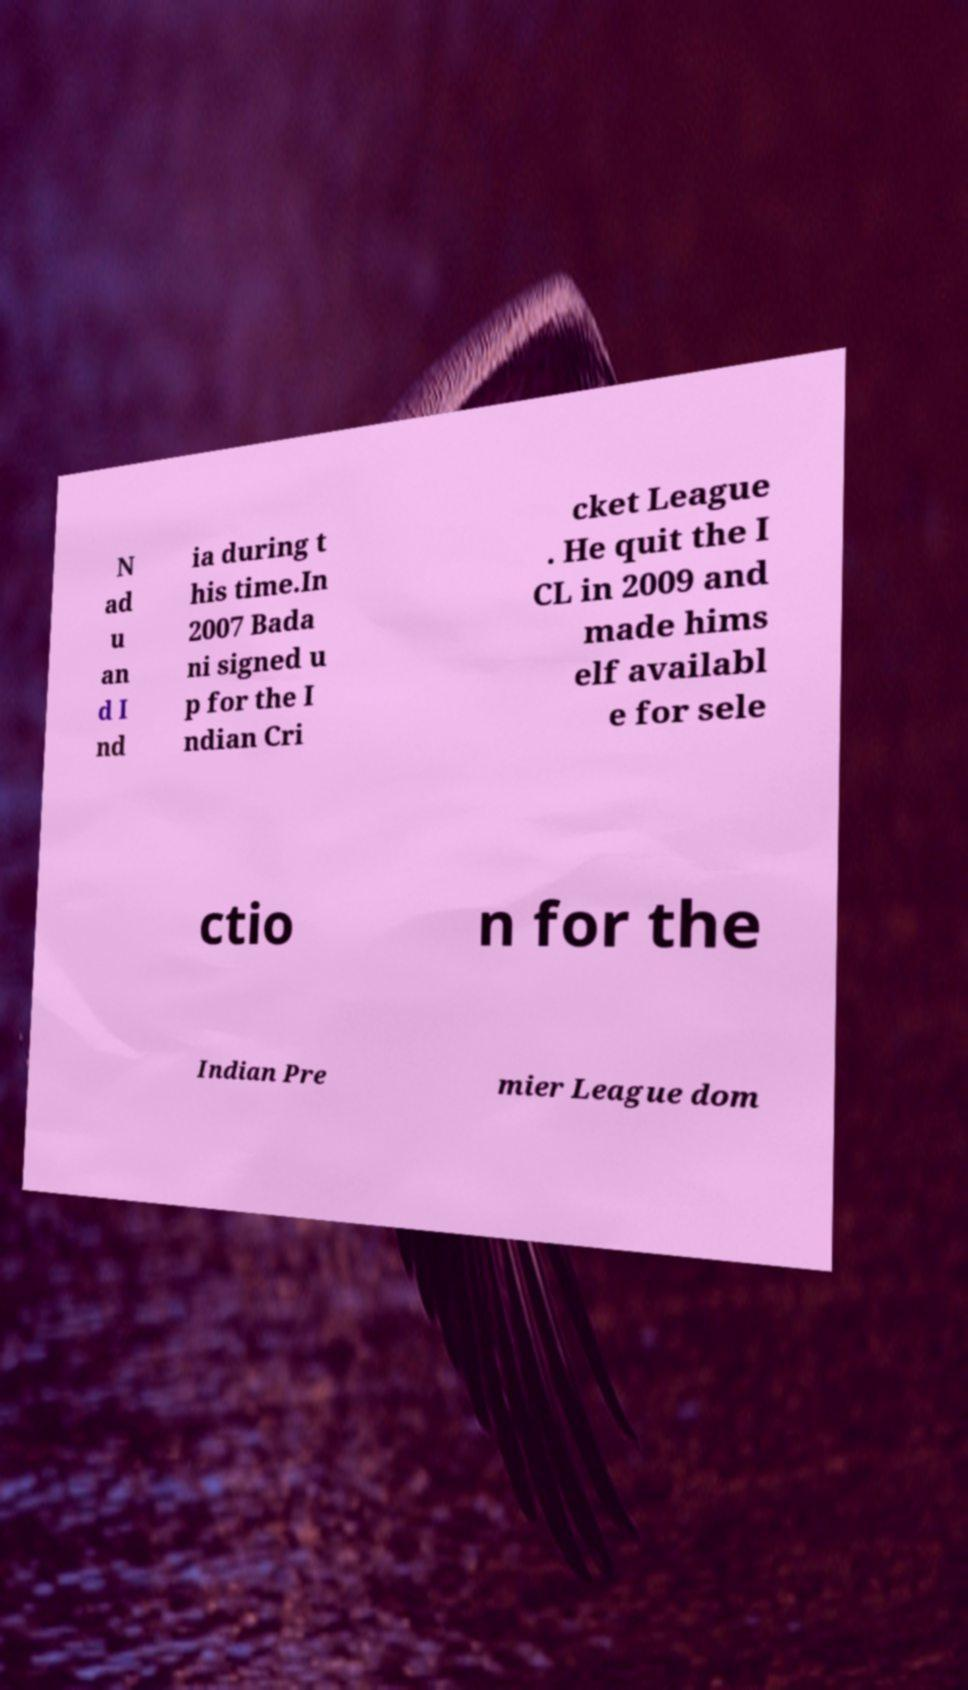For documentation purposes, I need the text within this image transcribed. Could you provide that? N ad u an d I nd ia during t his time.In 2007 Bada ni signed u p for the I ndian Cri cket League . He quit the I CL in 2009 and made hims elf availabl e for sele ctio n for the Indian Pre mier League dom 